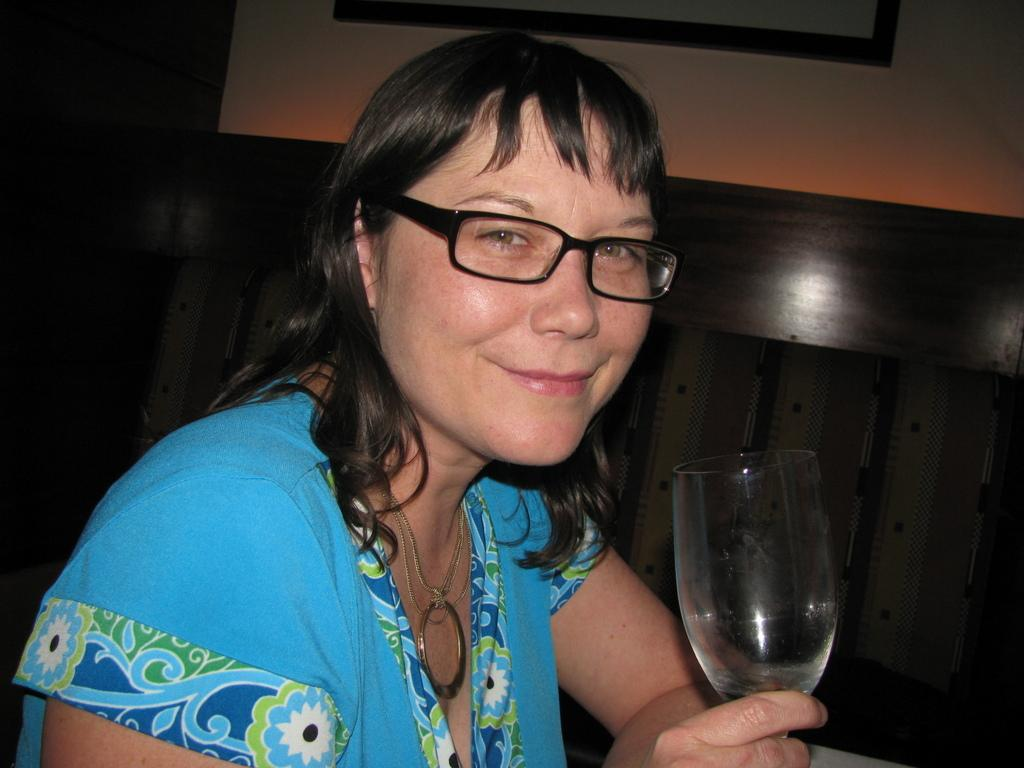Who is present in the image? There is a woman in the image. What is the woman wearing? The woman is wearing a blue dress. How is the woman's hair styled? The woman's hair is short. What expression does the woman have? The woman is smiling. What is the woman holding in the image? The woman is holding a glass. What can be seen in the background of the image? There is a wall and a photo frame in the background of the image. What type of winter activity is the woman participating in the image? There is no indication of winter or any winter activity in the image. How does the woman roll the ball in the image? There is no ball present in the image, so it is not possible to answer that question. 